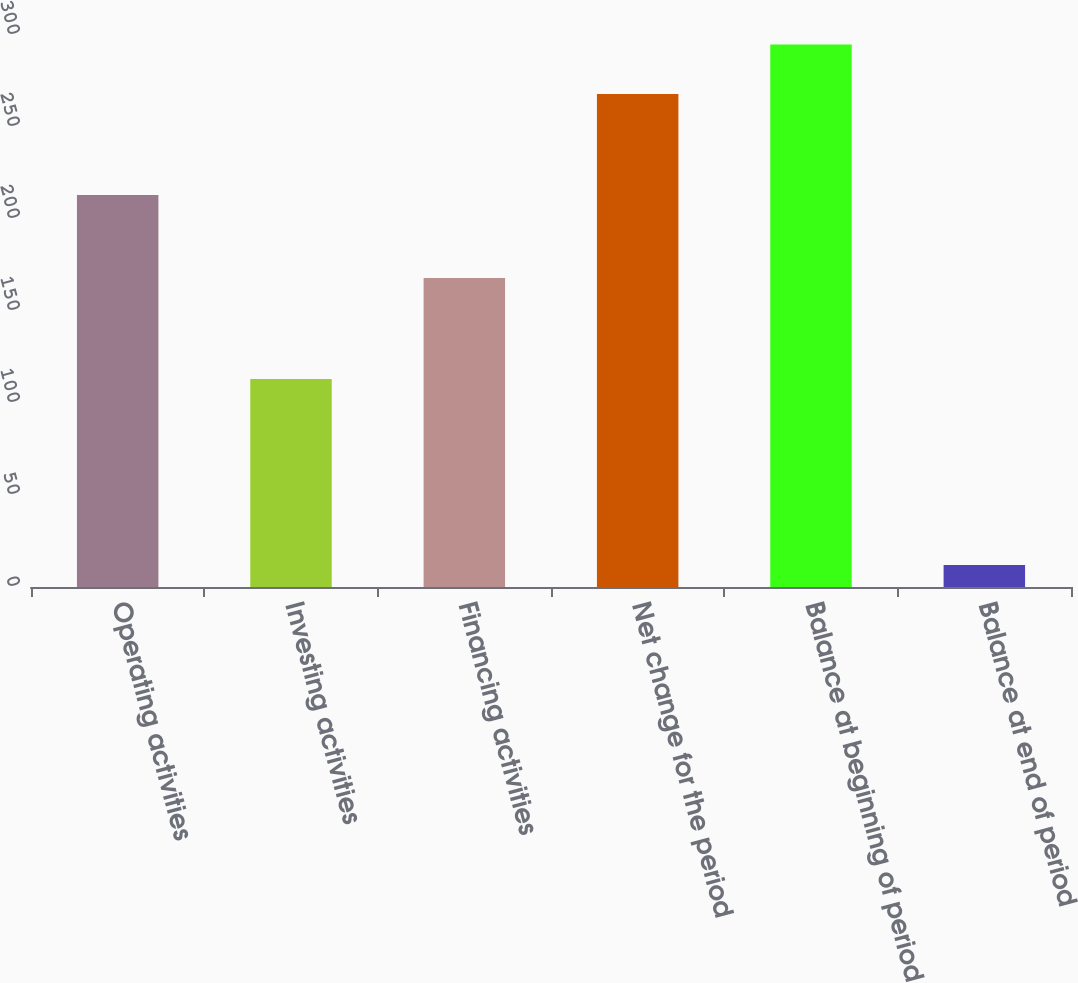Convert chart. <chart><loc_0><loc_0><loc_500><loc_500><bar_chart><fcel>Operating activities<fcel>Investing activities<fcel>Financing activities<fcel>Net change for the period<fcel>Balance at beginning of period<fcel>Balance at end of period<nl><fcel>213<fcel>113<fcel>168<fcel>268<fcel>294.8<fcel>12<nl></chart> 